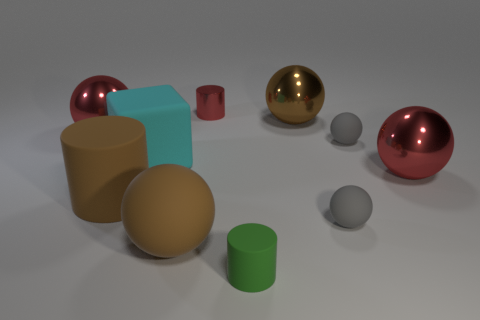There is a thing that is behind the cyan cube and on the left side of the cyan rubber object; what is its shape? The object you’re referring to has a spherical shape. It appears to be a small, gray sphere located behind the more prominently featured cyan cube and to the left of another object that exhibits a cylindrical form with a similar cyan hue. 